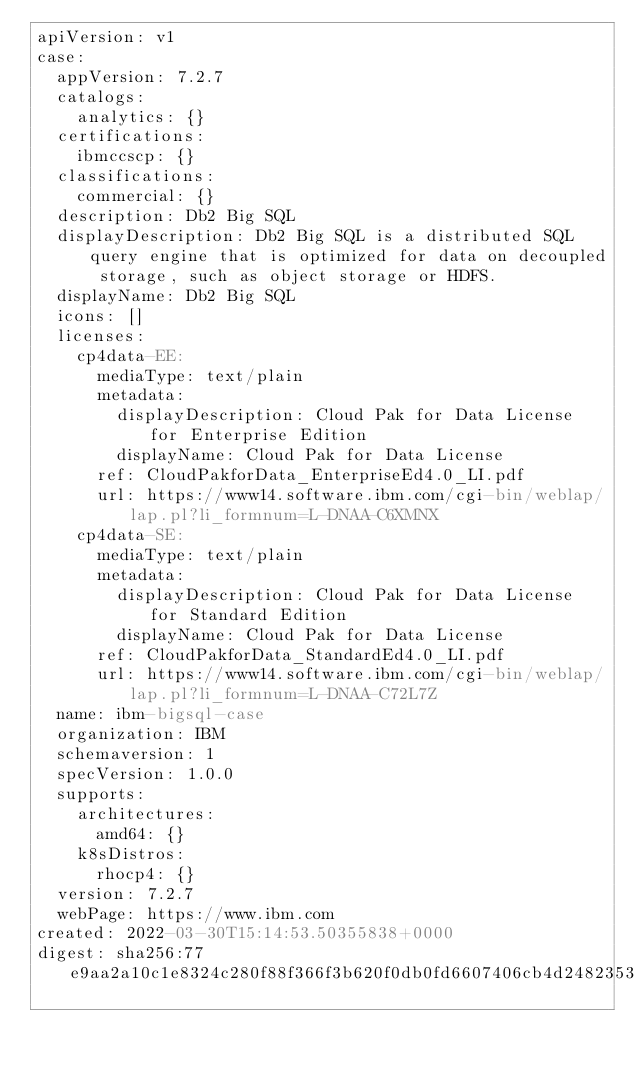<code> <loc_0><loc_0><loc_500><loc_500><_YAML_>apiVersion: v1
case:
  appVersion: 7.2.7
  catalogs:
    analytics: {}
  certifications:
    ibmccscp: {}
  classifications:
    commercial: {}
  description: Db2 Big SQL
  displayDescription: Db2 Big SQL is a distributed SQL query engine that is optimized for data on decoupled storage, such as object storage or HDFS.
  displayName: Db2 Big SQL
  icons: []
  licenses:
    cp4data-EE:
      mediaType: text/plain
      metadata:
        displayDescription: Cloud Pak for Data License for Enterprise Edition
        displayName: Cloud Pak for Data License
      ref: CloudPakforData_EnterpriseEd4.0_LI.pdf
      url: https://www14.software.ibm.com/cgi-bin/weblap/lap.pl?li_formnum=L-DNAA-C6XMNX
    cp4data-SE:
      mediaType: text/plain
      metadata:
        displayDescription: Cloud Pak for Data License for Standard Edition
        displayName: Cloud Pak for Data License
      ref: CloudPakforData_StandardEd4.0_LI.pdf
      url: https://www14.software.ibm.com/cgi-bin/weblap/lap.pl?li_formnum=L-DNAA-C72L7Z
  name: ibm-bigsql-case
  organization: IBM
  schemaversion: 1
  specVersion: 1.0.0
  supports:
    architectures:
      amd64: {}
    k8sDistros:
      rhocp4: {}
  version: 7.2.7
  webPage: https://www.ibm.com
created: 2022-03-30T15:14:53.50355838+0000
digest: sha256:77e9aa2a10c1e8324c280f88f366f3b620f0db0fd6607406cb4d248235355542
</code> 